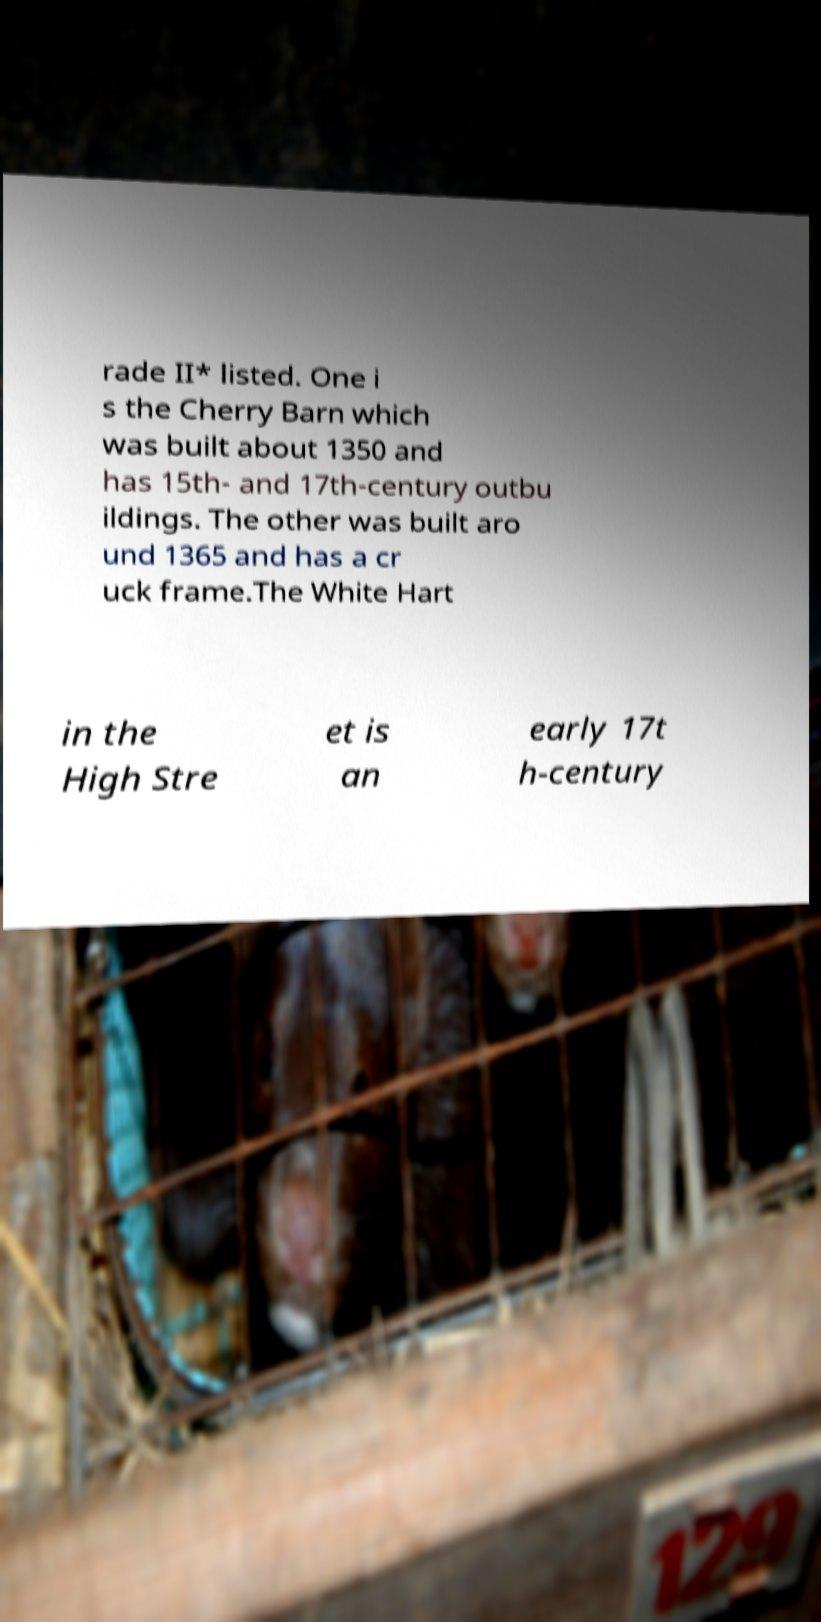There's text embedded in this image that I need extracted. Can you transcribe it verbatim? rade II* listed. One i s the Cherry Barn which was built about 1350 and has 15th- and 17th-century outbu ildings. The other was built aro und 1365 and has a cr uck frame.The White Hart in the High Stre et is an early 17t h-century 